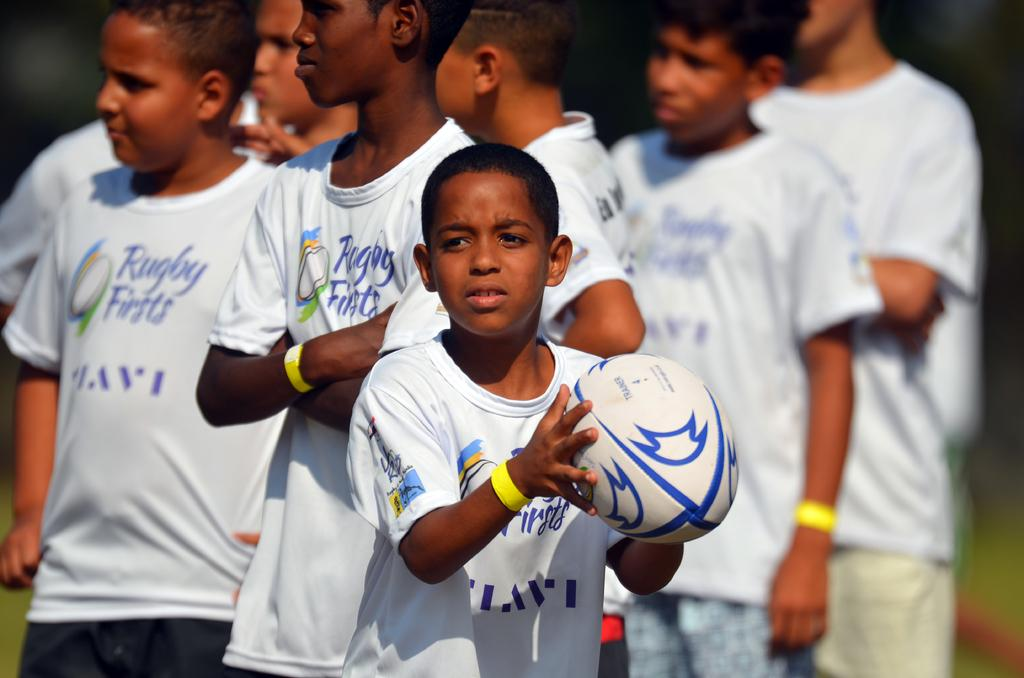<image>
Render a clear and concise summary of the photo. A group of children are wearing matching shirts that say Rugby Firsts. 